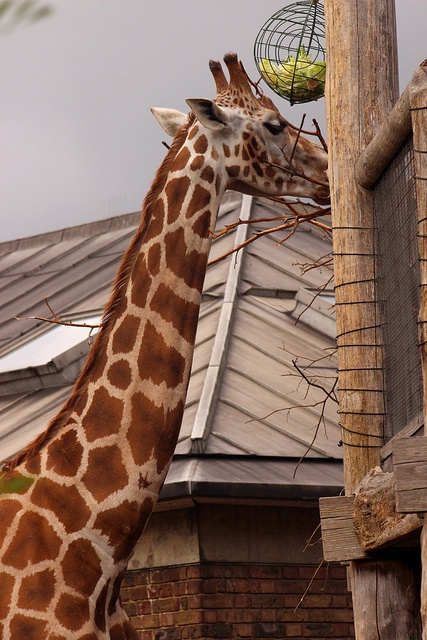Describe the objects in this image and their specific colors. I can see a giraffe in darkgray, maroon, gray, black, and tan tones in this image. 